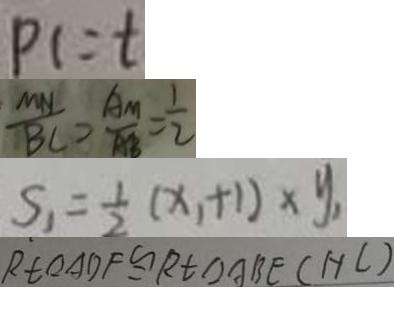Convert formula to latex. <formula><loc_0><loc_0><loc_500><loc_500>P C = t 
 \frac { M N } { B C } = \frac { A M } { A B } = \frac { 1 } { 2 } 
 S _ { 1 } = \frac { 1 } { 2 } ( x , + 1 ) \times y _ { 1 } 
 R t \Delta A D F \cong R t \Delta A B E ( H C )</formula> 